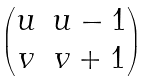Convert formula to latex. <formula><loc_0><loc_0><loc_500><loc_500>\begin{pmatrix} u & u - 1 \\ v & v + 1 \end{pmatrix}</formula> 